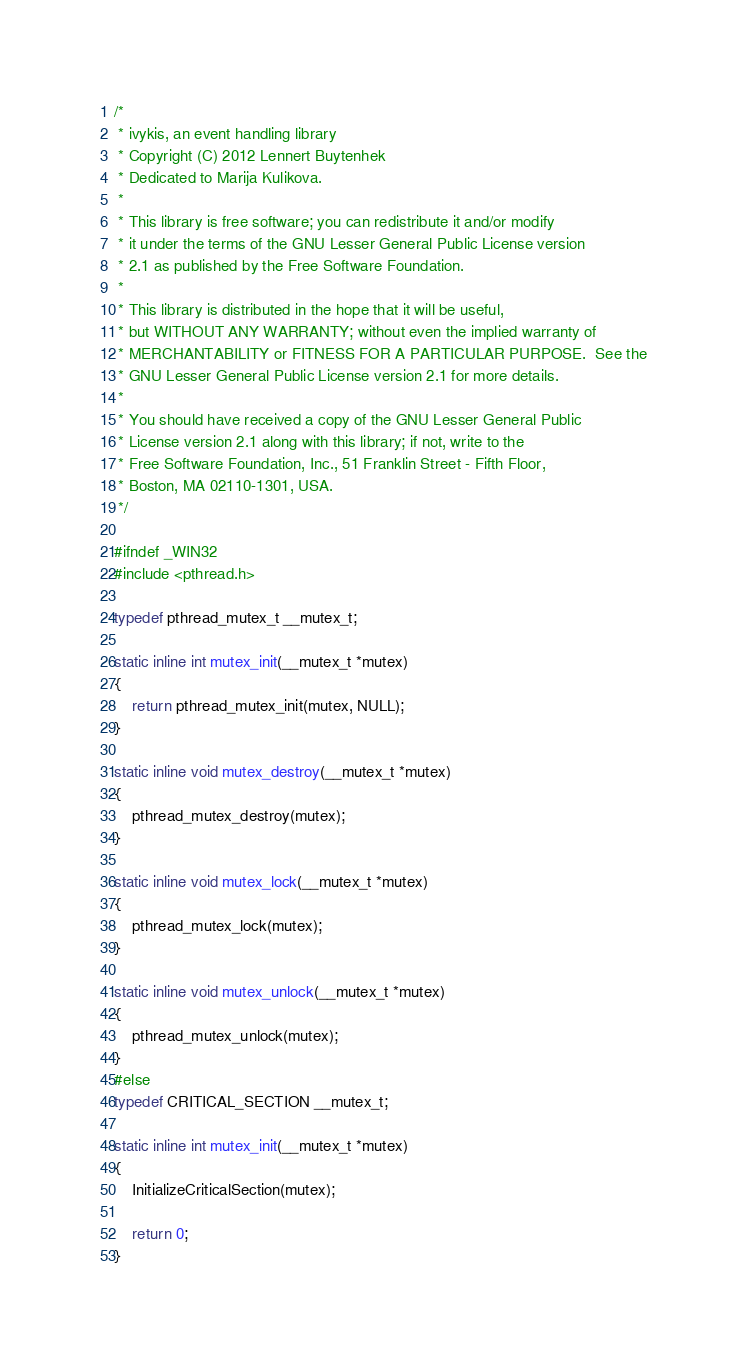Convert code to text. <code><loc_0><loc_0><loc_500><loc_500><_C_>/*
 * ivykis, an event handling library
 * Copyright (C) 2012 Lennert Buytenhek
 * Dedicated to Marija Kulikova.
 *
 * This library is free software; you can redistribute it and/or modify
 * it under the terms of the GNU Lesser General Public License version
 * 2.1 as published by the Free Software Foundation.
 *
 * This library is distributed in the hope that it will be useful,
 * but WITHOUT ANY WARRANTY; without even the implied warranty of
 * MERCHANTABILITY or FITNESS FOR A PARTICULAR PURPOSE.  See the
 * GNU Lesser General Public License version 2.1 for more details.
 *
 * You should have received a copy of the GNU Lesser General Public
 * License version 2.1 along with this library; if not, write to the
 * Free Software Foundation, Inc., 51 Franklin Street - Fifth Floor,
 * Boston, MA 02110-1301, USA.
 */

#ifndef _WIN32
#include <pthread.h>

typedef pthread_mutex_t __mutex_t;

static inline int mutex_init(__mutex_t *mutex)
{
	return pthread_mutex_init(mutex, NULL);
}

static inline void mutex_destroy(__mutex_t *mutex)
{
	pthread_mutex_destroy(mutex);
}

static inline void mutex_lock(__mutex_t *mutex)
{
	pthread_mutex_lock(mutex);
}

static inline void mutex_unlock(__mutex_t *mutex)
{
	pthread_mutex_unlock(mutex);
}
#else
typedef CRITICAL_SECTION __mutex_t;

static inline int mutex_init(__mutex_t *mutex)
{
	InitializeCriticalSection(mutex);

	return 0;
}
</code> 